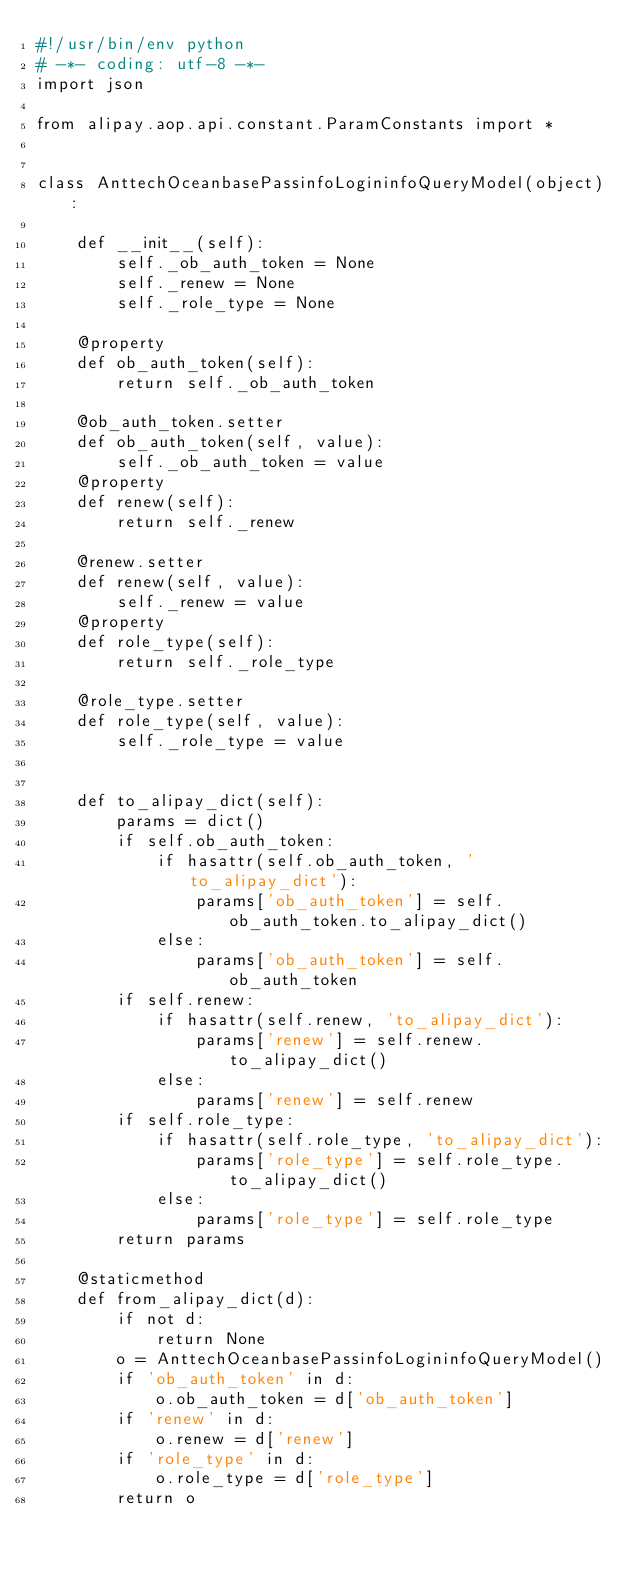<code> <loc_0><loc_0><loc_500><loc_500><_Python_>#!/usr/bin/env python
# -*- coding: utf-8 -*-
import json

from alipay.aop.api.constant.ParamConstants import *


class AnttechOceanbasePassinfoLogininfoQueryModel(object):

    def __init__(self):
        self._ob_auth_token = None
        self._renew = None
        self._role_type = None

    @property
    def ob_auth_token(self):
        return self._ob_auth_token

    @ob_auth_token.setter
    def ob_auth_token(self, value):
        self._ob_auth_token = value
    @property
    def renew(self):
        return self._renew

    @renew.setter
    def renew(self, value):
        self._renew = value
    @property
    def role_type(self):
        return self._role_type

    @role_type.setter
    def role_type(self, value):
        self._role_type = value


    def to_alipay_dict(self):
        params = dict()
        if self.ob_auth_token:
            if hasattr(self.ob_auth_token, 'to_alipay_dict'):
                params['ob_auth_token'] = self.ob_auth_token.to_alipay_dict()
            else:
                params['ob_auth_token'] = self.ob_auth_token
        if self.renew:
            if hasattr(self.renew, 'to_alipay_dict'):
                params['renew'] = self.renew.to_alipay_dict()
            else:
                params['renew'] = self.renew
        if self.role_type:
            if hasattr(self.role_type, 'to_alipay_dict'):
                params['role_type'] = self.role_type.to_alipay_dict()
            else:
                params['role_type'] = self.role_type
        return params

    @staticmethod
    def from_alipay_dict(d):
        if not d:
            return None
        o = AnttechOceanbasePassinfoLogininfoQueryModel()
        if 'ob_auth_token' in d:
            o.ob_auth_token = d['ob_auth_token']
        if 'renew' in d:
            o.renew = d['renew']
        if 'role_type' in d:
            o.role_type = d['role_type']
        return o


</code> 